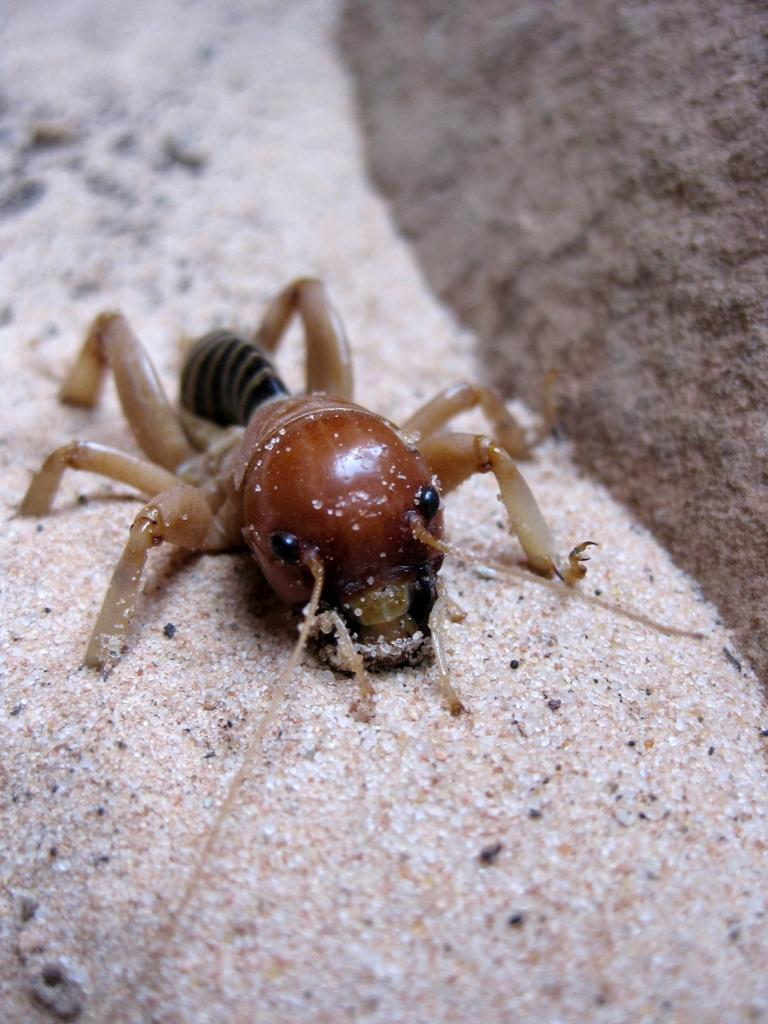What type of creature is in the image? There is an insect in the image. Where is the insect located? The insect is on the sand. What type of wool is the owl using to build its nest in the image? There is no owl or wool present in the image; it features an insect on the sand. 